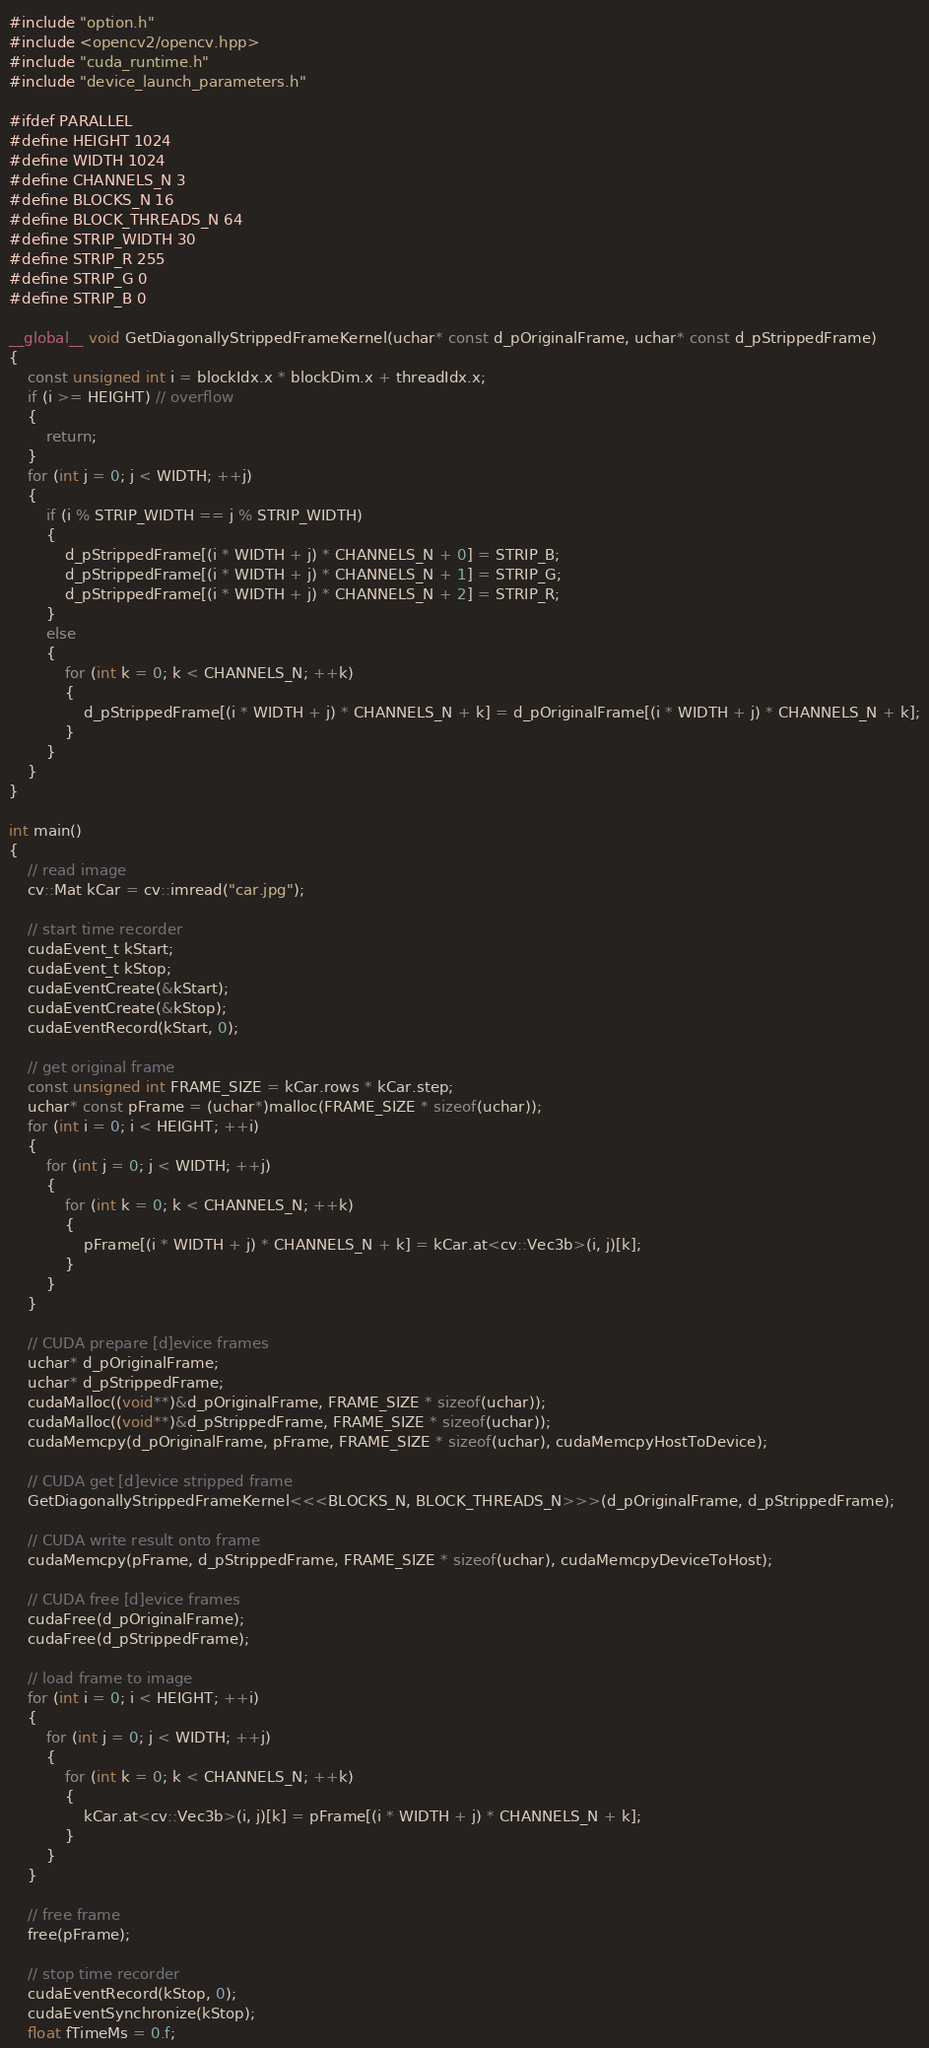<code> <loc_0><loc_0><loc_500><loc_500><_Cuda_>#include "option.h"
#include <opencv2/opencv.hpp>
#include "cuda_runtime.h"
#include "device_launch_parameters.h"

#ifdef PARALLEL
#define HEIGHT 1024
#define WIDTH 1024
#define CHANNELS_N 3
#define BLOCKS_N 16
#define BLOCK_THREADS_N 64
#define STRIP_WIDTH 30
#define STRIP_R 255
#define STRIP_G 0
#define STRIP_B 0

__global__ void GetDiagonallyStrippedFrameKernel(uchar* const d_pOriginalFrame, uchar* const d_pStrippedFrame)
{
    const unsigned int i = blockIdx.x * blockDim.x + threadIdx.x;
    if (i >= HEIGHT) // overflow
    {
        return;
    }
    for (int j = 0; j < WIDTH; ++j)
    {
        if (i % STRIP_WIDTH == j % STRIP_WIDTH)
        {
            d_pStrippedFrame[(i * WIDTH + j) * CHANNELS_N + 0] = STRIP_B;
            d_pStrippedFrame[(i * WIDTH + j) * CHANNELS_N + 1] = STRIP_G;
            d_pStrippedFrame[(i * WIDTH + j) * CHANNELS_N + 2] = STRIP_R;
        }
        else
        {
            for (int k = 0; k < CHANNELS_N; ++k)
            {
                d_pStrippedFrame[(i * WIDTH + j) * CHANNELS_N + k] = d_pOriginalFrame[(i * WIDTH + j) * CHANNELS_N + k];
            }
        }
    }
}

int main()
{
    // read image
    cv::Mat kCar = cv::imread("car.jpg");

    // start time recorder
    cudaEvent_t kStart;
    cudaEvent_t kStop;
    cudaEventCreate(&kStart);
    cudaEventCreate(&kStop);
    cudaEventRecord(kStart, 0);

    // get original frame
    const unsigned int FRAME_SIZE = kCar.rows * kCar.step;
    uchar* const pFrame = (uchar*)malloc(FRAME_SIZE * sizeof(uchar));
    for (int i = 0; i < HEIGHT; ++i)
    {
        for (int j = 0; j < WIDTH; ++j)
        {
            for (int k = 0; k < CHANNELS_N; ++k)
            {
                pFrame[(i * WIDTH + j) * CHANNELS_N + k] = kCar.at<cv::Vec3b>(i, j)[k];
            }
        }
    }

    // CUDA prepare [d]evice frames
    uchar* d_pOriginalFrame;
    uchar* d_pStrippedFrame;
    cudaMalloc((void**)&d_pOriginalFrame, FRAME_SIZE * sizeof(uchar));
    cudaMalloc((void**)&d_pStrippedFrame, FRAME_SIZE * sizeof(uchar));
    cudaMemcpy(d_pOriginalFrame, pFrame, FRAME_SIZE * sizeof(uchar), cudaMemcpyHostToDevice);

    // CUDA get [d]evice stripped frame
    GetDiagonallyStrippedFrameKernel<<<BLOCKS_N, BLOCK_THREADS_N>>>(d_pOriginalFrame, d_pStrippedFrame);

    // CUDA write result onto frame
    cudaMemcpy(pFrame, d_pStrippedFrame, FRAME_SIZE * sizeof(uchar), cudaMemcpyDeviceToHost);

    // CUDA free [d]evice frames
    cudaFree(d_pOriginalFrame);
    cudaFree(d_pStrippedFrame);

    // load frame to image
    for (int i = 0; i < HEIGHT; ++i)
    {
        for (int j = 0; j < WIDTH; ++j)
        {
            for (int k = 0; k < CHANNELS_N; ++k)
            {
                kCar.at<cv::Vec3b>(i, j)[k] = pFrame[(i * WIDTH + j) * CHANNELS_N + k];
            }
        }
    }

    // free frame
    free(pFrame);

    // stop time recorder
    cudaEventRecord(kStop, 0);
    cudaEventSynchronize(kStop);
    float fTimeMs = 0.f;</code> 